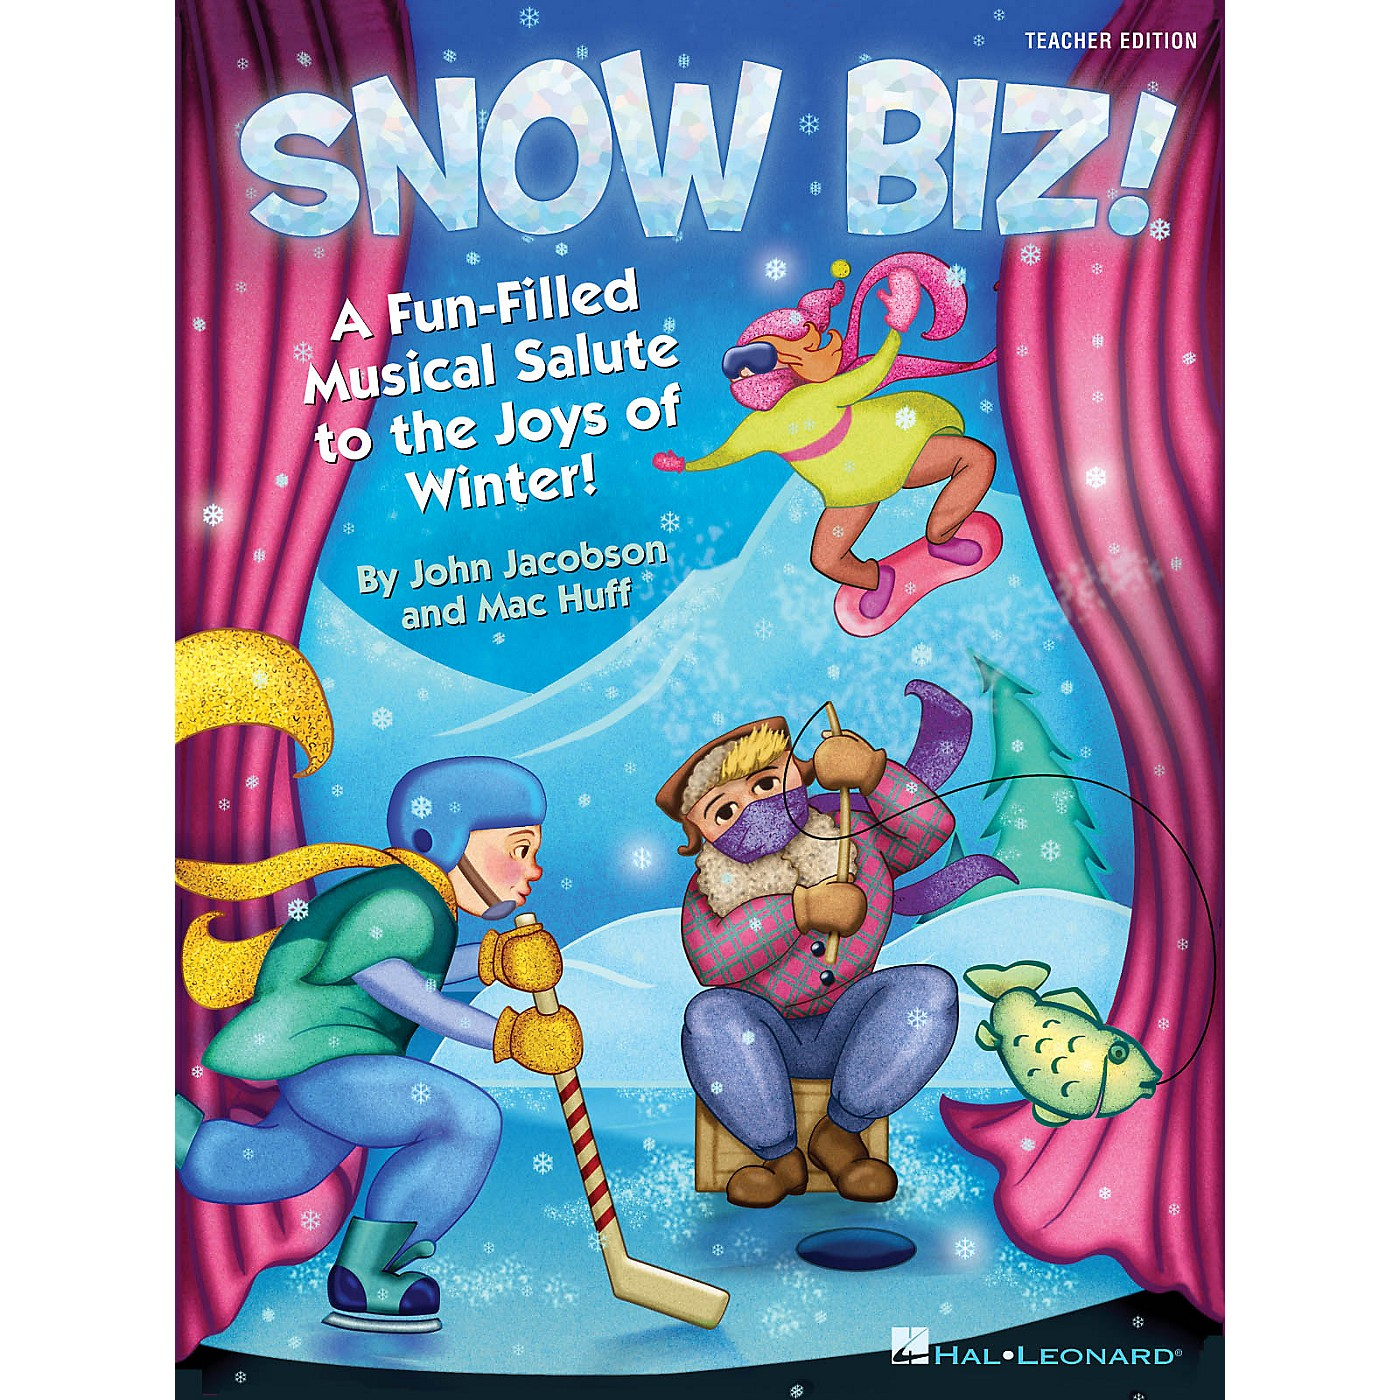Imagine a scenario where the characters in the image come to life. What sort of adventures might they embark on? If the characters in the image were to come to life, they might embark on a series of exciting and varied winter adventures. The hockey player could lead a friendly game, teaching others the basics of the sport and emphasizing teamwork and healthy competition. The ice fisher character might organize a fishing tournament, where the group learns the patience and skill needed to catch fish, perhaps discovering magical, talking fish that share riddles or stories from the icy depths. The leaping character in bright attire could incite everyone to join in a snowman-building contest or a lively snowball fight, fostering camaraderie and exuberance. Together, these adventures would blend action, skill-building, and pure fun, making the winter experience memorable and educational for all involved.  If the scene included a magical portal behind the curtain, where might it lead, and how would it fit into the theme of joy and winter? The magical portal behind the curtain could lead to a fantastical winter wonderland, a place where the joys of winter are magnified through enchanted landscapes and whimsical experiences. As the characters step through the portal, they might find themselves in a sparkling forest with trees made of candy canes and snowflakes that sing as they fall. There could be a castle made of ice where a jovial winter king hosts grand festivals and concerts, teaching the characters about different winter traditions and musical expressions. Fitting into the theme of joy and winter, this magical land would offer endless opportunities for fun, learning, and wonder. Characters might race down ever-changing ice slides, participate in enchanted sleigh rides, and learn to create beautiful ice sculptures with the wave of a hand. The portal would symbolically and literally open up new realms of winter delights, reinforcing the limitless joy and imagination that winter can bring. 